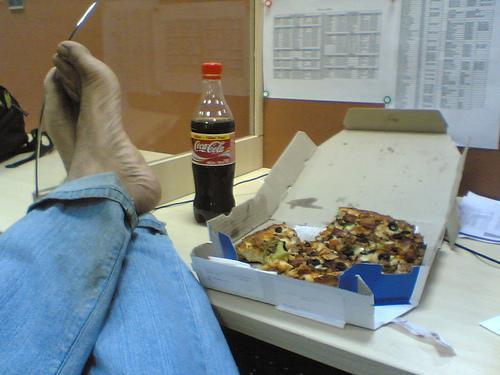How many levels on this bus are red?
Give a very brief answer. 0. 